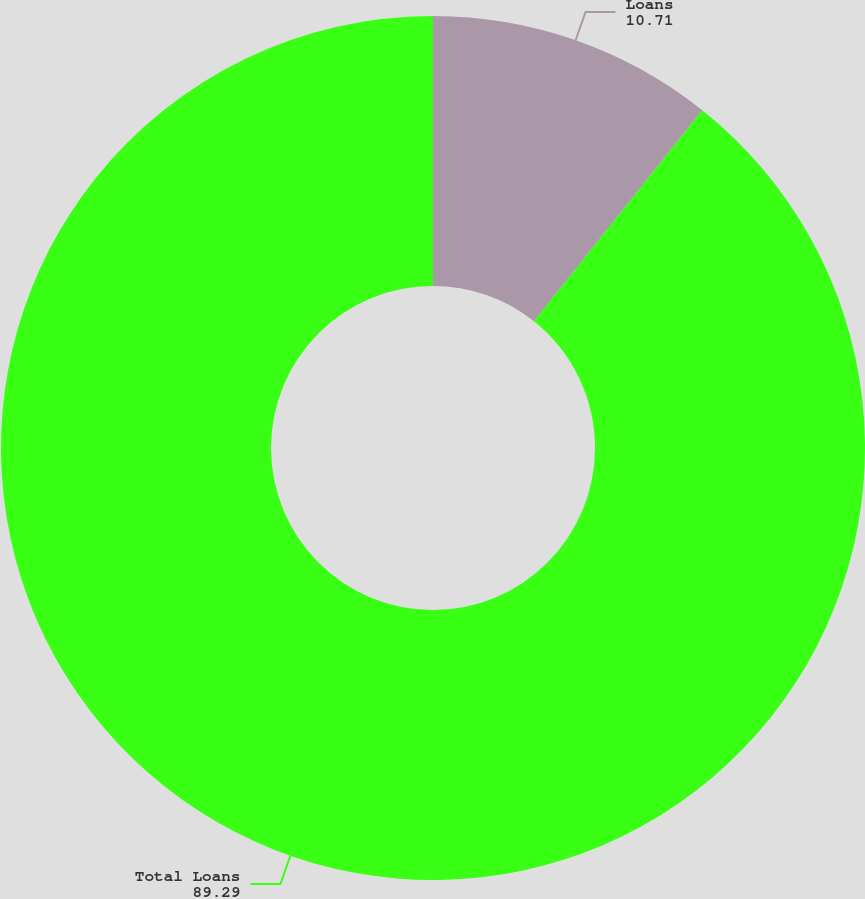Convert chart to OTSL. <chart><loc_0><loc_0><loc_500><loc_500><pie_chart><fcel>Loans<fcel>Total Loans<nl><fcel>10.71%<fcel>89.29%<nl></chart> 